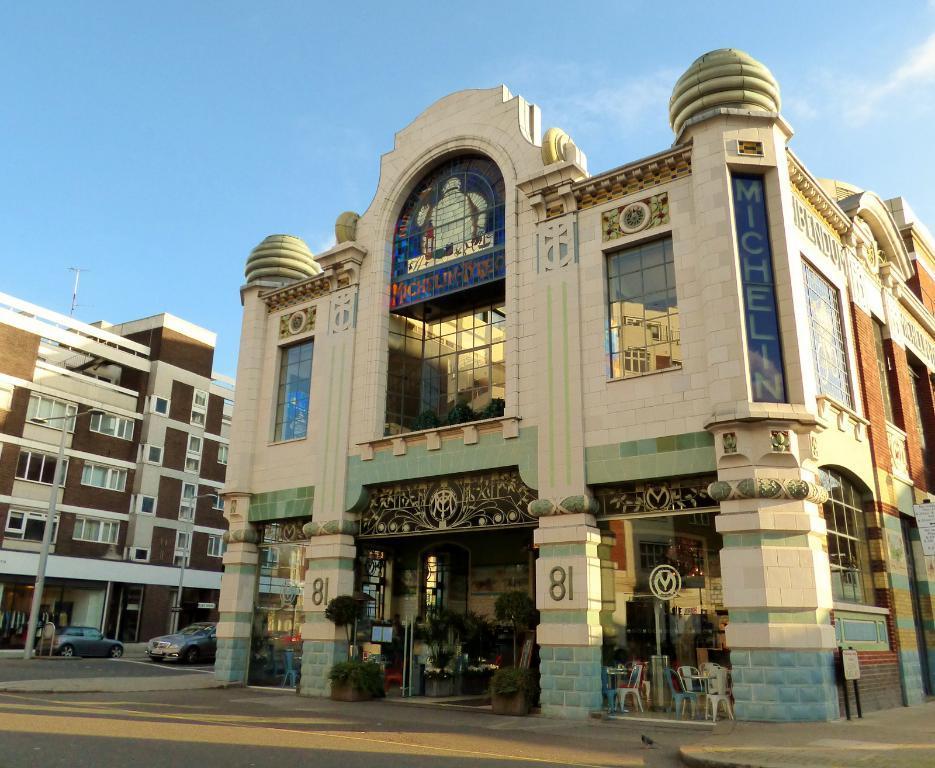Can you describe this image briefly? This image is taken outdoors. At the top of the image there is the sky with clouds. At the bottom of the image there is a road. On the left side of the image there is a building with walls, windows, doors, balconies and a roof. There is a pole with street lights. Two cars are moving on the road. In the middle of the image there is a building with walls, doors and pillars. There are a few carvings on the walls. There are a few plants in the pots. There are many empty chairs and there is a board. 